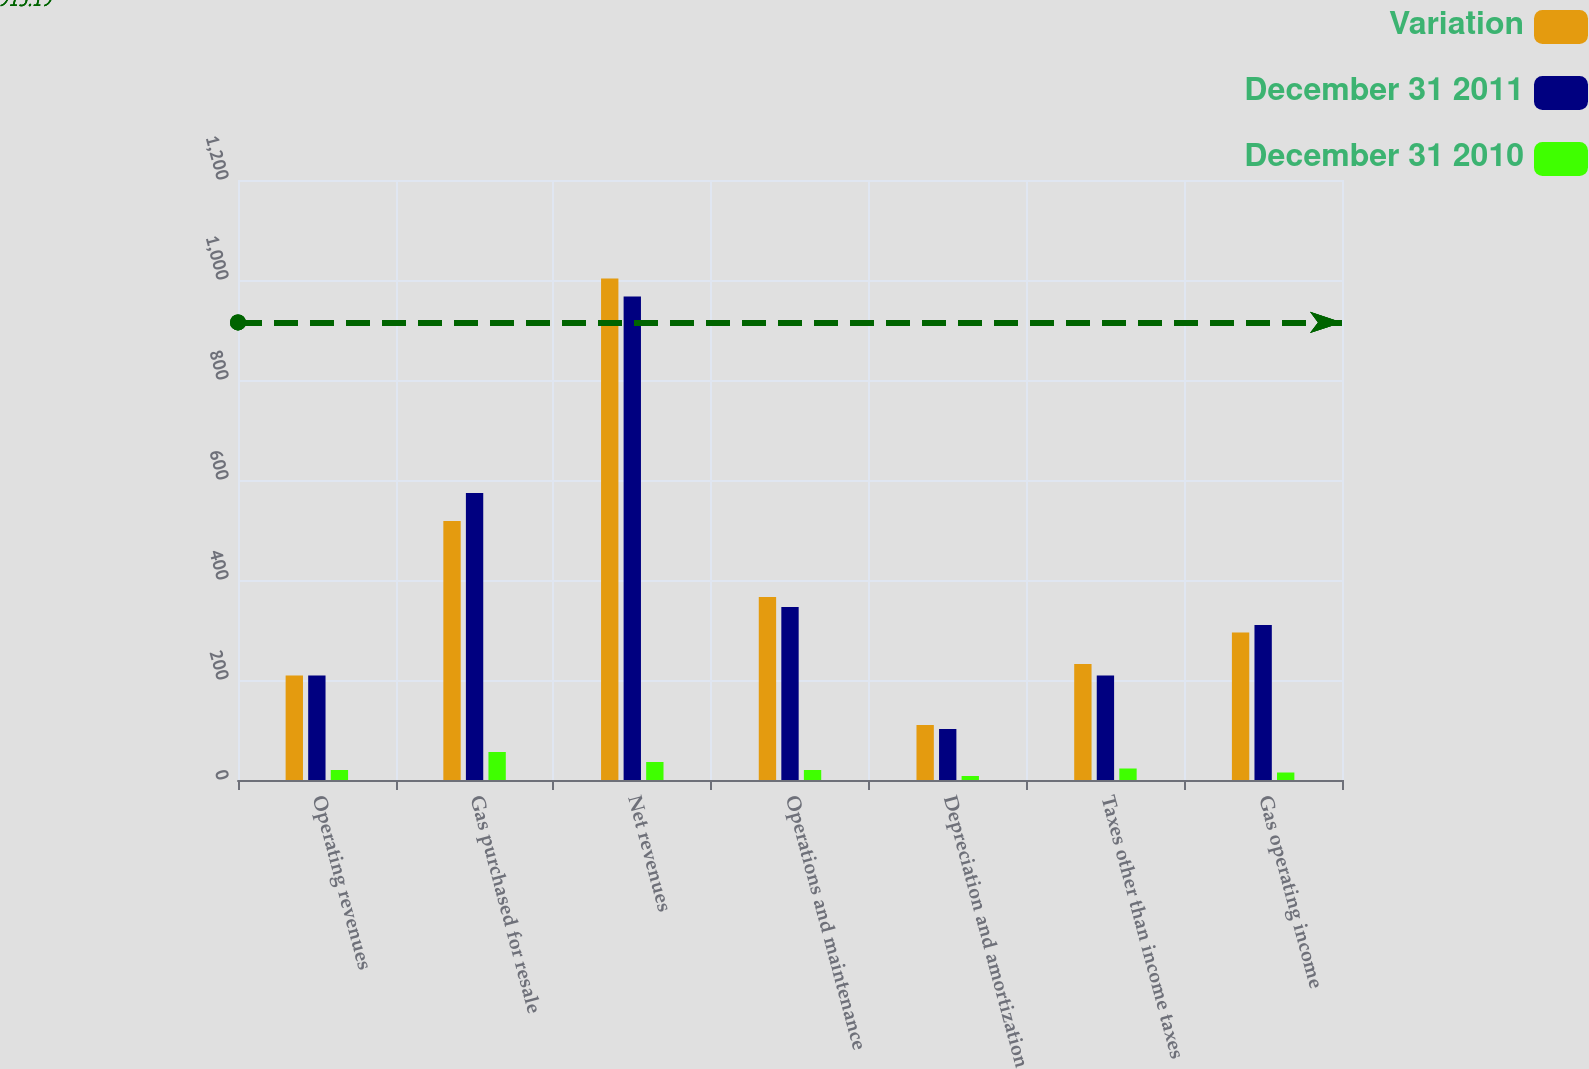Convert chart. <chart><loc_0><loc_0><loc_500><loc_500><stacked_bar_chart><ecel><fcel>Operating revenues<fcel>Gas purchased for resale<fcel>Net revenues<fcel>Operations and maintenance<fcel>Depreciation and amortization<fcel>Taxes other than income taxes<fcel>Gas operating income<nl><fcel>Variation<fcel>209<fcel>518<fcel>1003<fcel>366<fcel>110<fcel>232<fcel>295<nl><fcel>December 31 2011<fcel>209<fcel>574<fcel>967<fcel>346<fcel>102<fcel>209<fcel>310<nl><fcel>December 31 2010<fcel>20<fcel>56<fcel>36<fcel>20<fcel>8<fcel>23<fcel>15<nl></chart> 